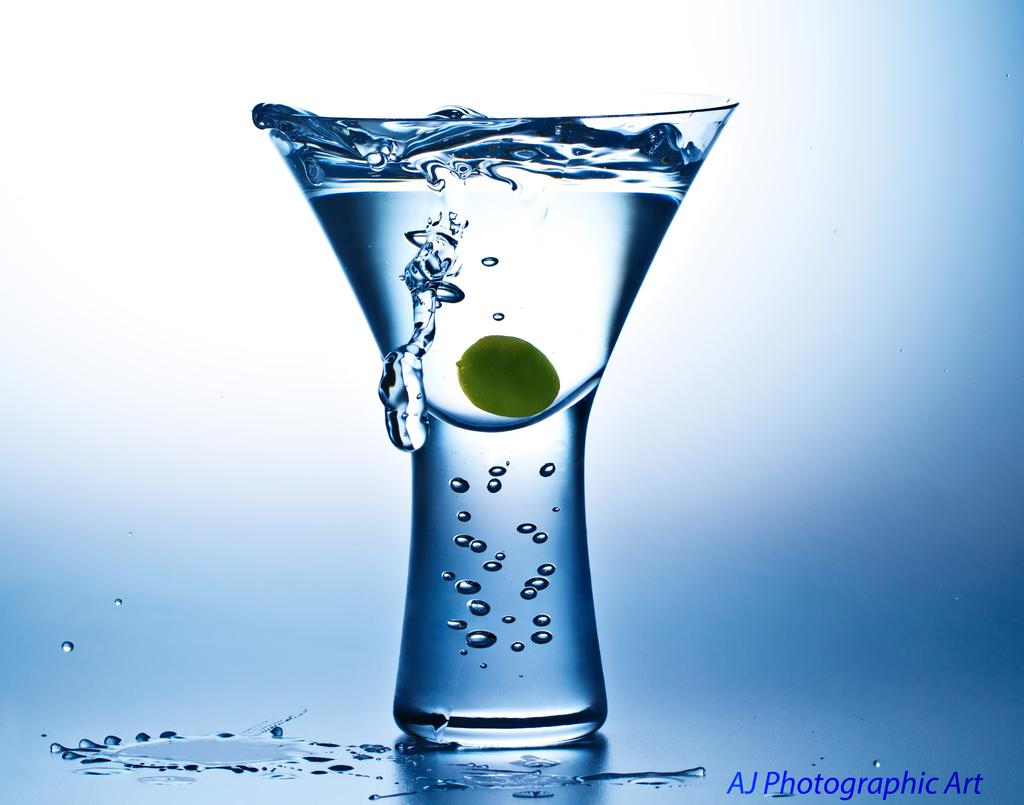What is in the glass that is visible in the image? There is a glass with water in the image. What is inside the glass besides water? There is an item inside the glass. Can you describe any additional features of the image? There is a watermark on the image. What type of servant can be seen attending to the glass in the image? There is no servant present in the image. How does the love between the two individuals in the image manifest itself? There are no individuals or any indication of love in the image. 